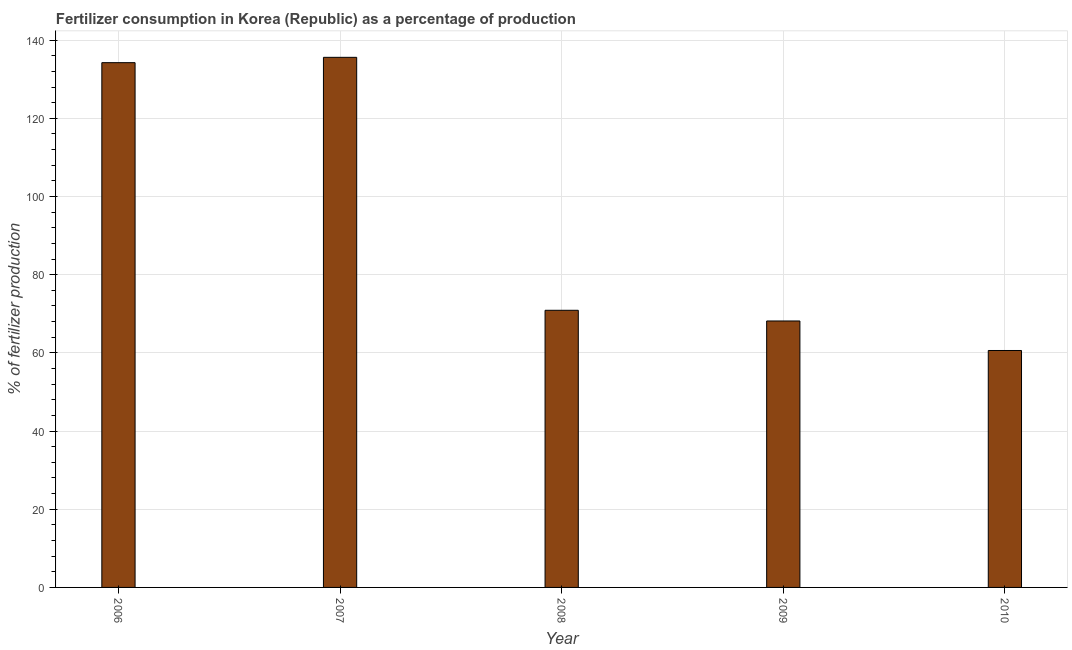What is the title of the graph?
Ensure brevity in your answer.  Fertilizer consumption in Korea (Republic) as a percentage of production. What is the label or title of the X-axis?
Ensure brevity in your answer.  Year. What is the label or title of the Y-axis?
Keep it short and to the point. % of fertilizer production. What is the amount of fertilizer consumption in 2008?
Ensure brevity in your answer.  70.89. Across all years, what is the maximum amount of fertilizer consumption?
Ensure brevity in your answer.  135.6. Across all years, what is the minimum amount of fertilizer consumption?
Ensure brevity in your answer.  60.61. In which year was the amount of fertilizer consumption minimum?
Keep it short and to the point. 2010. What is the sum of the amount of fertilizer consumption?
Your answer should be very brief. 469.49. What is the difference between the amount of fertilizer consumption in 2008 and 2010?
Give a very brief answer. 10.28. What is the average amount of fertilizer consumption per year?
Provide a succinct answer. 93.9. What is the median amount of fertilizer consumption?
Provide a short and direct response. 70.89. Do a majority of the years between 2010 and 2007 (inclusive) have amount of fertilizer consumption greater than 36 %?
Offer a terse response. Yes. What is the ratio of the amount of fertilizer consumption in 2006 to that in 2010?
Make the answer very short. 2.21. What is the difference between the highest and the second highest amount of fertilizer consumption?
Your response must be concise. 1.36. Is the sum of the amount of fertilizer consumption in 2008 and 2010 greater than the maximum amount of fertilizer consumption across all years?
Your response must be concise. No. What is the difference between the highest and the lowest amount of fertilizer consumption?
Give a very brief answer. 74.99. Are all the bars in the graph horizontal?
Provide a succinct answer. No. What is the difference between two consecutive major ticks on the Y-axis?
Offer a very short reply. 20. Are the values on the major ticks of Y-axis written in scientific E-notation?
Offer a very short reply. No. What is the % of fertilizer production of 2006?
Your response must be concise. 134.23. What is the % of fertilizer production in 2007?
Make the answer very short. 135.6. What is the % of fertilizer production in 2008?
Offer a terse response. 70.89. What is the % of fertilizer production in 2009?
Your answer should be very brief. 68.16. What is the % of fertilizer production in 2010?
Your response must be concise. 60.61. What is the difference between the % of fertilizer production in 2006 and 2007?
Your response must be concise. -1.36. What is the difference between the % of fertilizer production in 2006 and 2008?
Your answer should be very brief. 63.34. What is the difference between the % of fertilizer production in 2006 and 2009?
Provide a succinct answer. 66.07. What is the difference between the % of fertilizer production in 2006 and 2010?
Ensure brevity in your answer.  73.62. What is the difference between the % of fertilizer production in 2007 and 2008?
Make the answer very short. 64.71. What is the difference between the % of fertilizer production in 2007 and 2009?
Make the answer very short. 67.44. What is the difference between the % of fertilizer production in 2007 and 2010?
Your answer should be very brief. 74.99. What is the difference between the % of fertilizer production in 2008 and 2009?
Offer a terse response. 2.73. What is the difference between the % of fertilizer production in 2008 and 2010?
Ensure brevity in your answer.  10.28. What is the difference between the % of fertilizer production in 2009 and 2010?
Keep it short and to the point. 7.55. What is the ratio of the % of fertilizer production in 2006 to that in 2007?
Offer a very short reply. 0.99. What is the ratio of the % of fertilizer production in 2006 to that in 2008?
Your response must be concise. 1.89. What is the ratio of the % of fertilizer production in 2006 to that in 2009?
Your answer should be compact. 1.97. What is the ratio of the % of fertilizer production in 2006 to that in 2010?
Provide a short and direct response. 2.21. What is the ratio of the % of fertilizer production in 2007 to that in 2008?
Ensure brevity in your answer.  1.91. What is the ratio of the % of fertilizer production in 2007 to that in 2009?
Give a very brief answer. 1.99. What is the ratio of the % of fertilizer production in 2007 to that in 2010?
Your answer should be very brief. 2.24. What is the ratio of the % of fertilizer production in 2008 to that in 2010?
Your answer should be very brief. 1.17. What is the ratio of the % of fertilizer production in 2009 to that in 2010?
Ensure brevity in your answer.  1.12. 